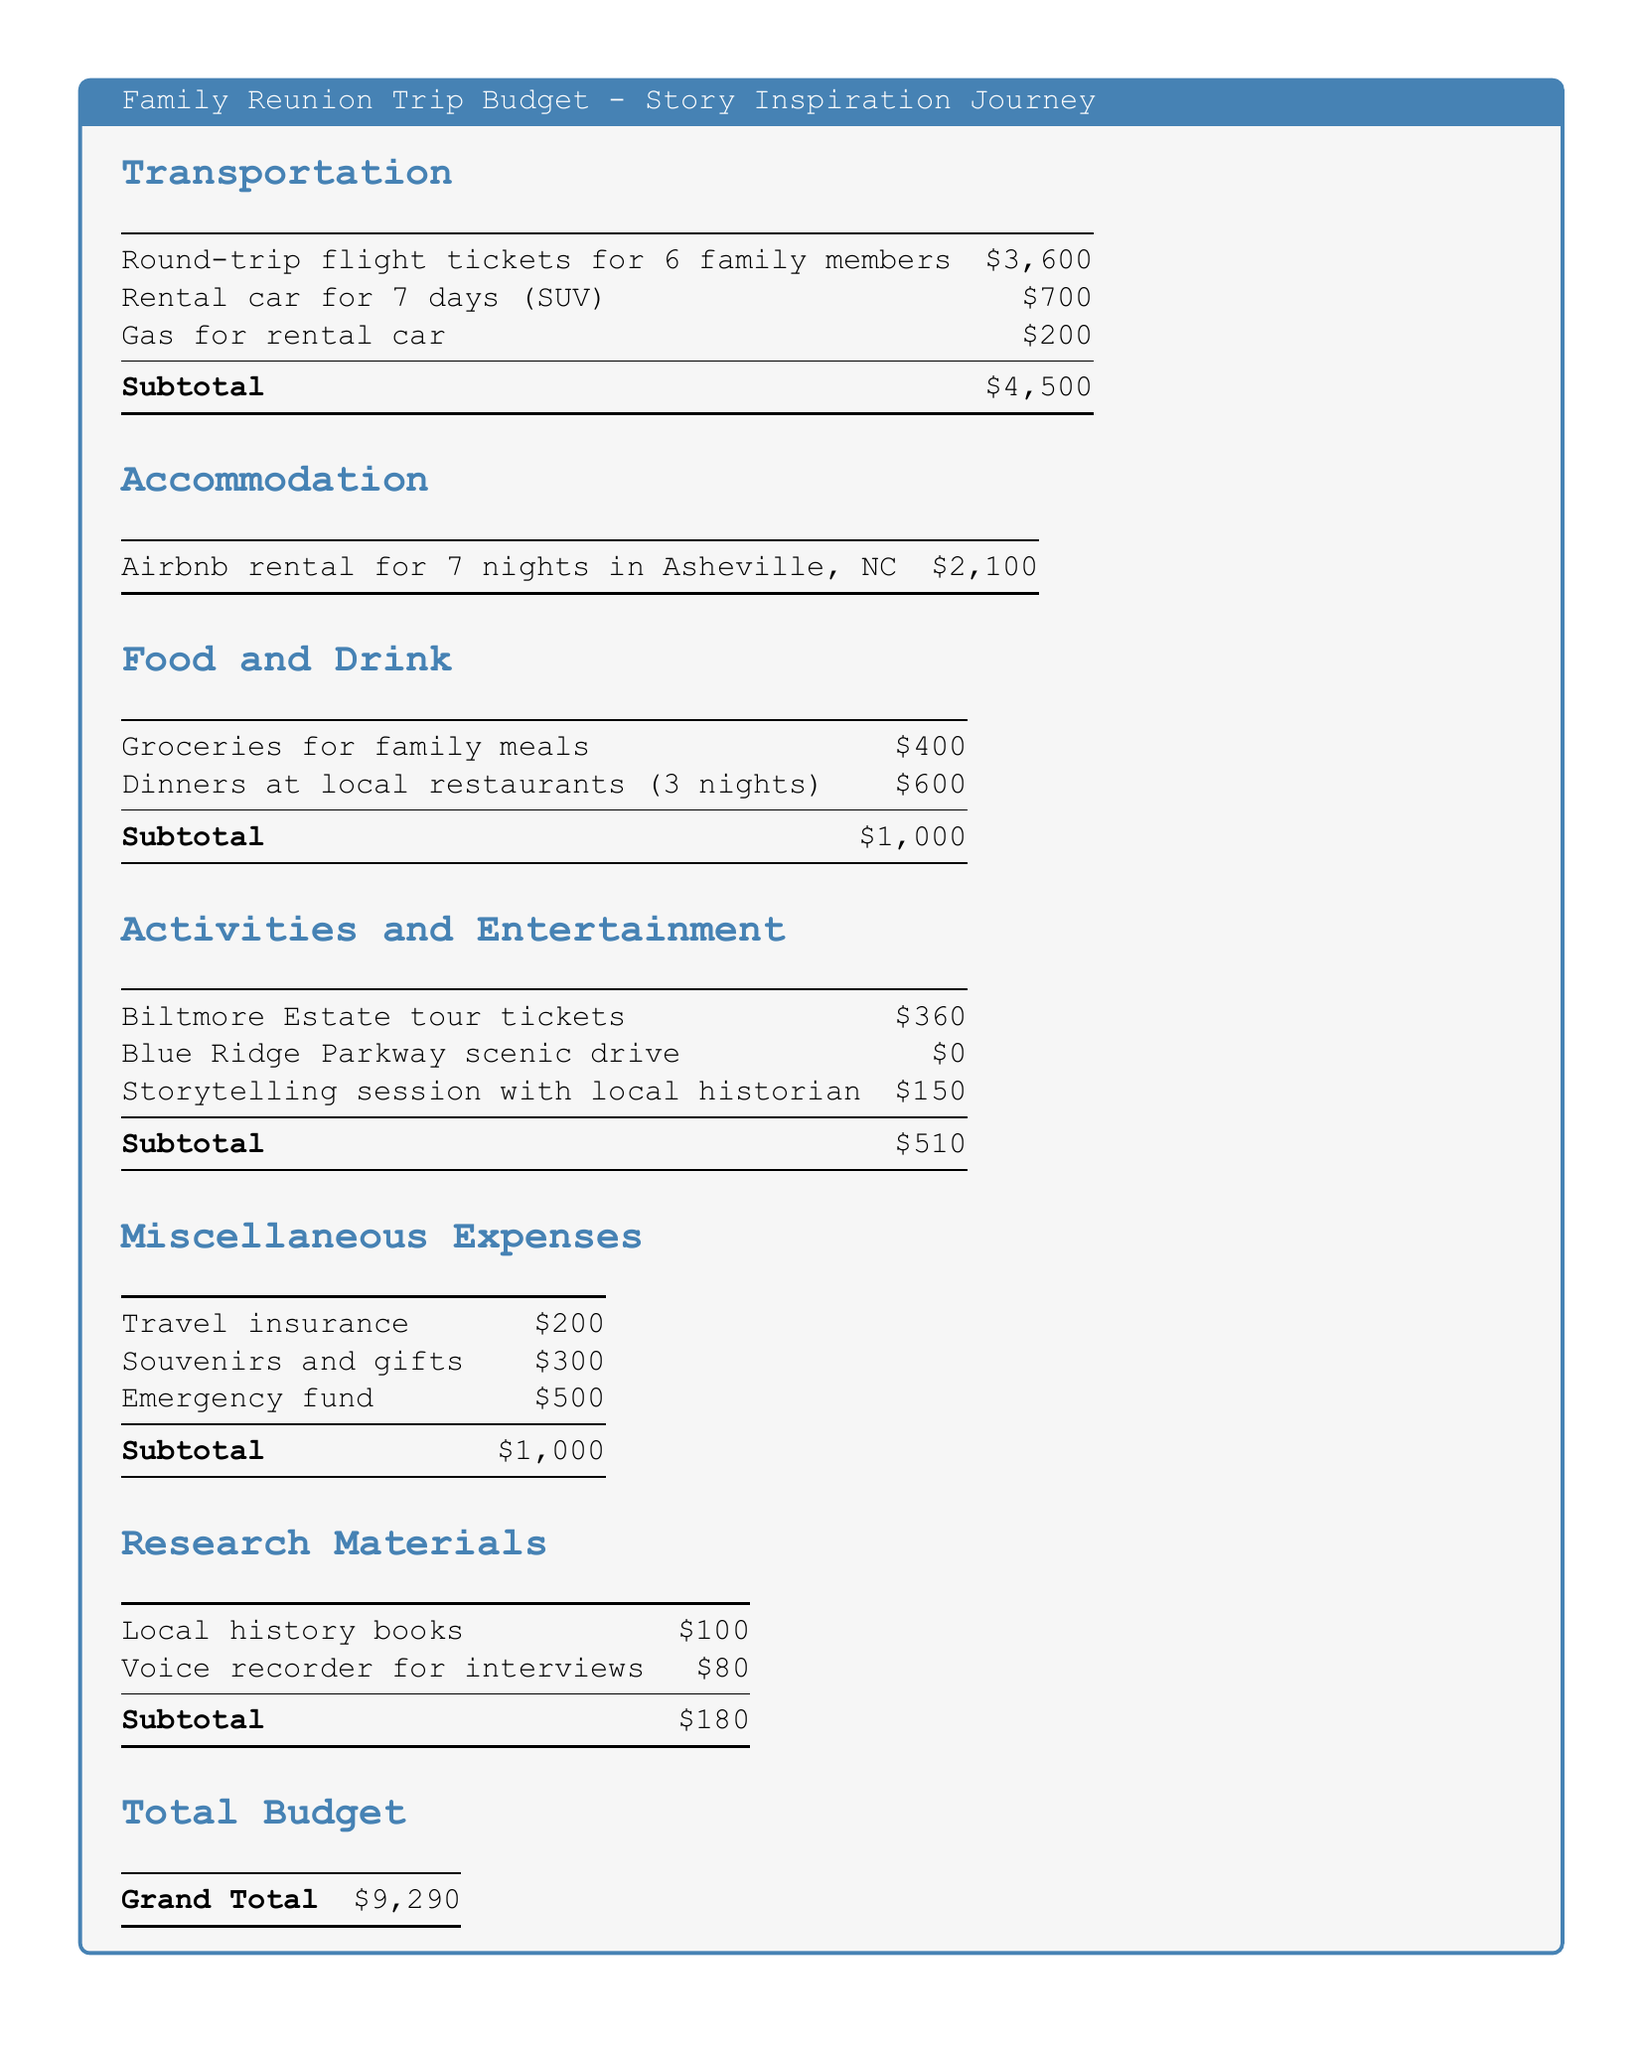What is the total budget for the family reunion trip? The total budget is listed as the grand total at the end of the document, which combines all expenses.
Answer: $9,290 How much was spent on transportation? The transportation section summarizes the costs related to travel, including flights and rental car expenses.
Answer: $4,500 What is the cost of groceries for family meals? The cost for groceries is specified in the food and drink section of the document.
Answer: $400 How much was allocated for research materials? The research materials expenses are detailed as part of the budget, specifically mentioning local history books and a voice recorder.
Answer: $180 What is the cost of the Biltmore Estate tour tickets? The specific expense for the Biltmore Estate tour is included in the activities and entertainment section.
Answer: $360 How many nights is the Airbnb rental for? The accommodation section mentions the duration of the stay in the Airbnb rental.
Answer: 7 nights What is the total cost for dinners at local restaurants? The total cost for dining out is outlined under food and drink, indicating how many nights were budgeted for restaurants.
Answer: $600 What is the amount set aside for the emergency fund? The miscellaneous expenses section includes the emergency fund expense along with other items.
Answer: $500 How much did the family budget for souvenirs and gifts? The miscellaneous expenses also mention the budget allocated for souvenirs and gifts.
Answer: $300 